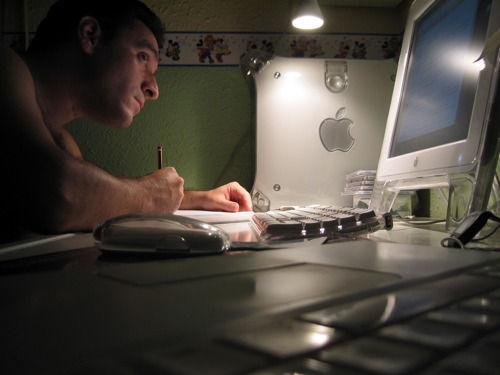Is there a keyboard in the picture?
Short answer required. Yes. What kind of computer is he using?
Keep it brief. Apple. Is the man writing?
Give a very brief answer. Yes. What color pen is this woman holding?
Be succinct. Black. Is this person happy?
Be succinct. No. What color is the paint on the wall?
Short answer required. Green. 